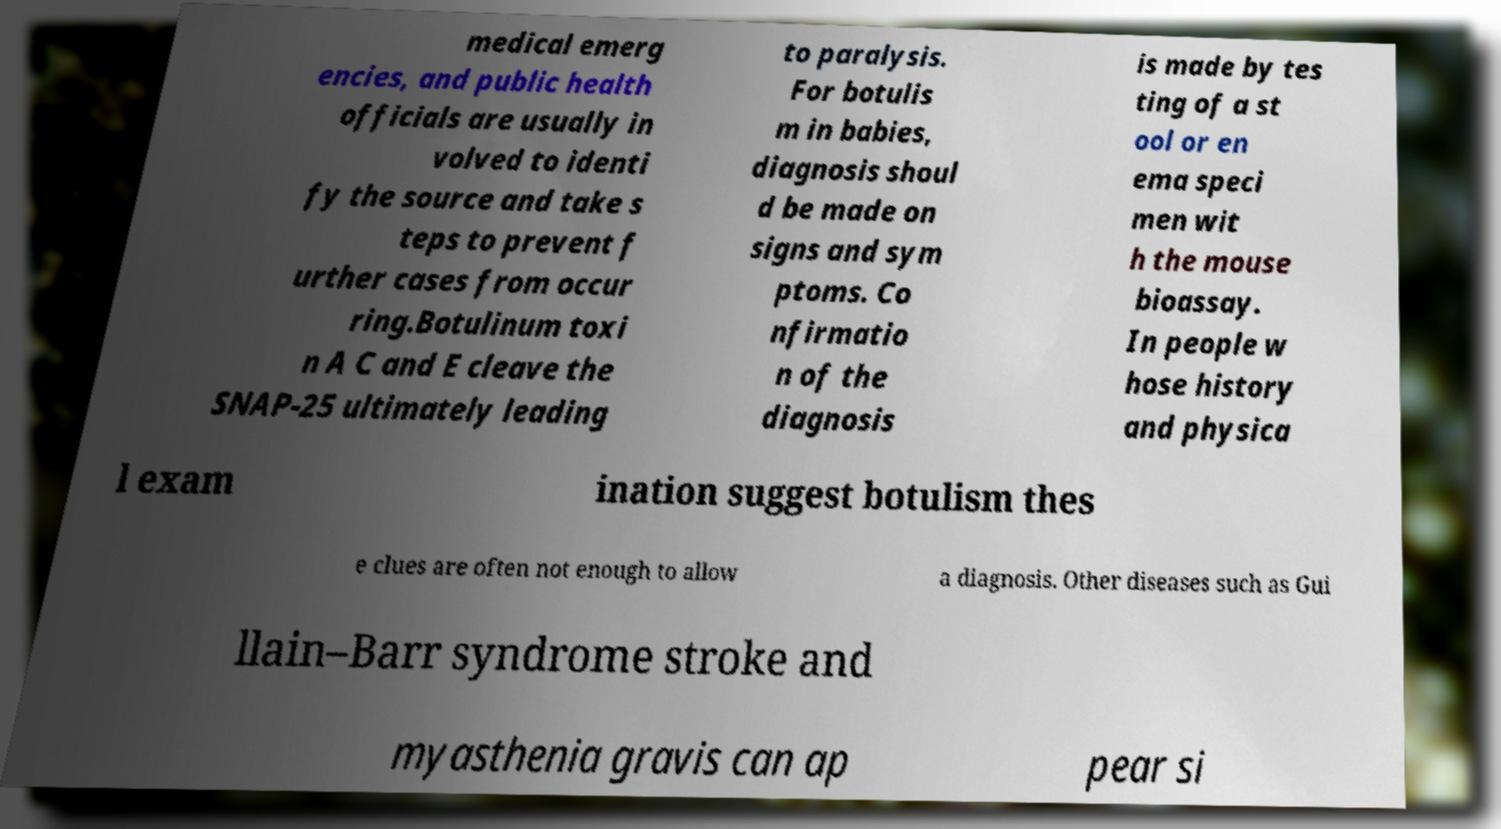What messages or text are displayed in this image? I need them in a readable, typed format. medical emerg encies, and public health officials are usually in volved to identi fy the source and take s teps to prevent f urther cases from occur ring.Botulinum toxi n A C and E cleave the SNAP-25 ultimately leading to paralysis. For botulis m in babies, diagnosis shoul d be made on signs and sym ptoms. Co nfirmatio n of the diagnosis is made by tes ting of a st ool or en ema speci men wit h the mouse bioassay. In people w hose history and physica l exam ination suggest botulism thes e clues are often not enough to allow a diagnosis. Other diseases such as Gui llain–Barr syndrome stroke and myasthenia gravis can ap pear si 